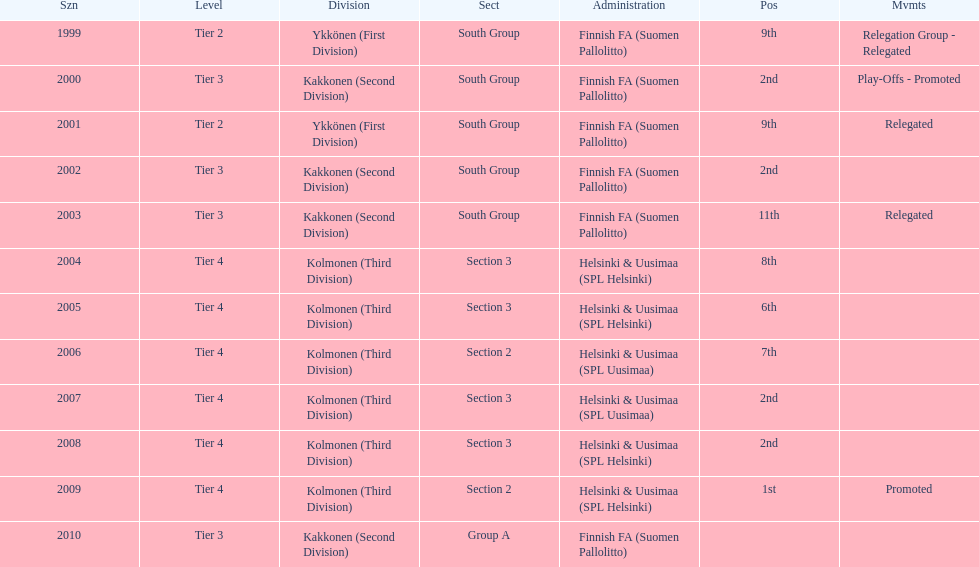How many tiers had more than one relegated movement? 1. 